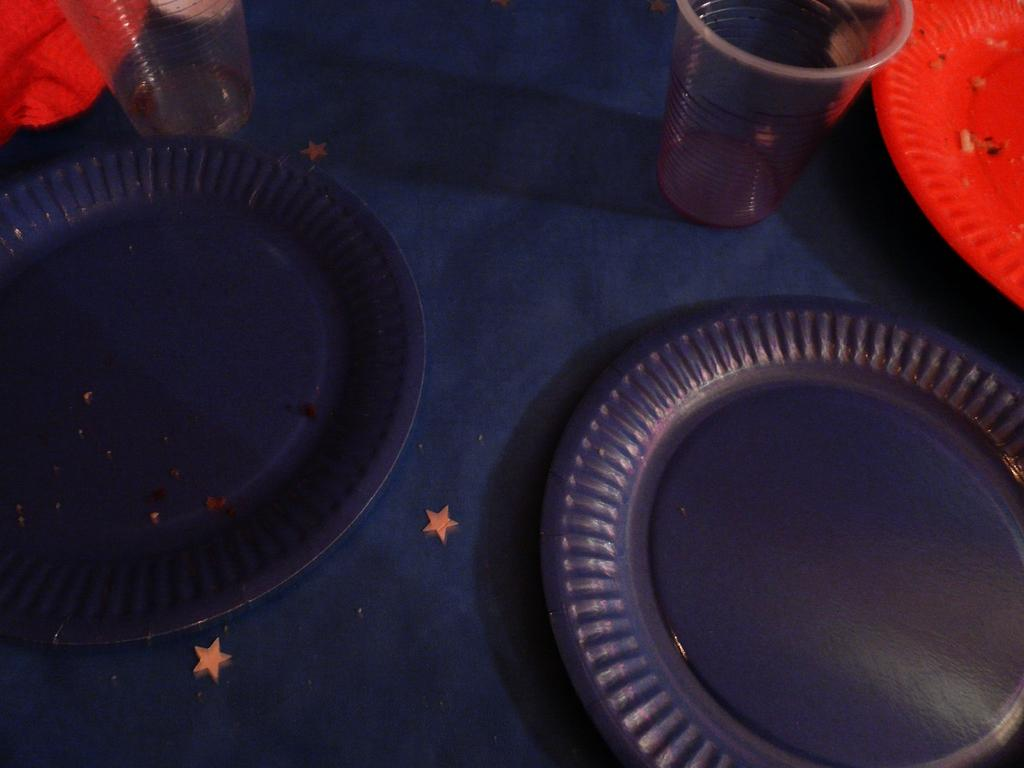What is on the table in the image? There is a water glass, red plates, and blue plates on the table. What colors are the plates on the table? The plates on the table are red and blue. What is the color of the cloth on the table? The cloth on the table is blue. What type of plant can be seen growing on the table in the image? There is no plant visible on the table in the image. What kind of noise can be heard coming from the plates in the image? There is no noise coming from the plates in the image, as they are stationary objects. 